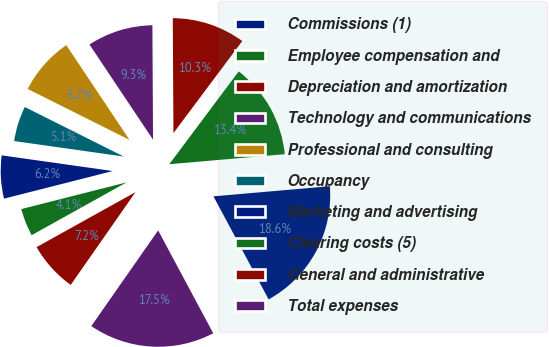Convert chart to OTSL. <chart><loc_0><loc_0><loc_500><loc_500><pie_chart><fcel>Commissions (1)<fcel>Employee compensation and<fcel>Depreciation and amortization<fcel>Technology and communications<fcel>Professional and consulting<fcel>Occupancy<fcel>Marketing and advertising<fcel>Clearing costs (5)<fcel>General and administrative<fcel>Total expenses<nl><fcel>18.56%<fcel>13.4%<fcel>10.31%<fcel>9.28%<fcel>8.25%<fcel>5.15%<fcel>6.19%<fcel>4.12%<fcel>7.22%<fcel>17.53%<nl></chart> 